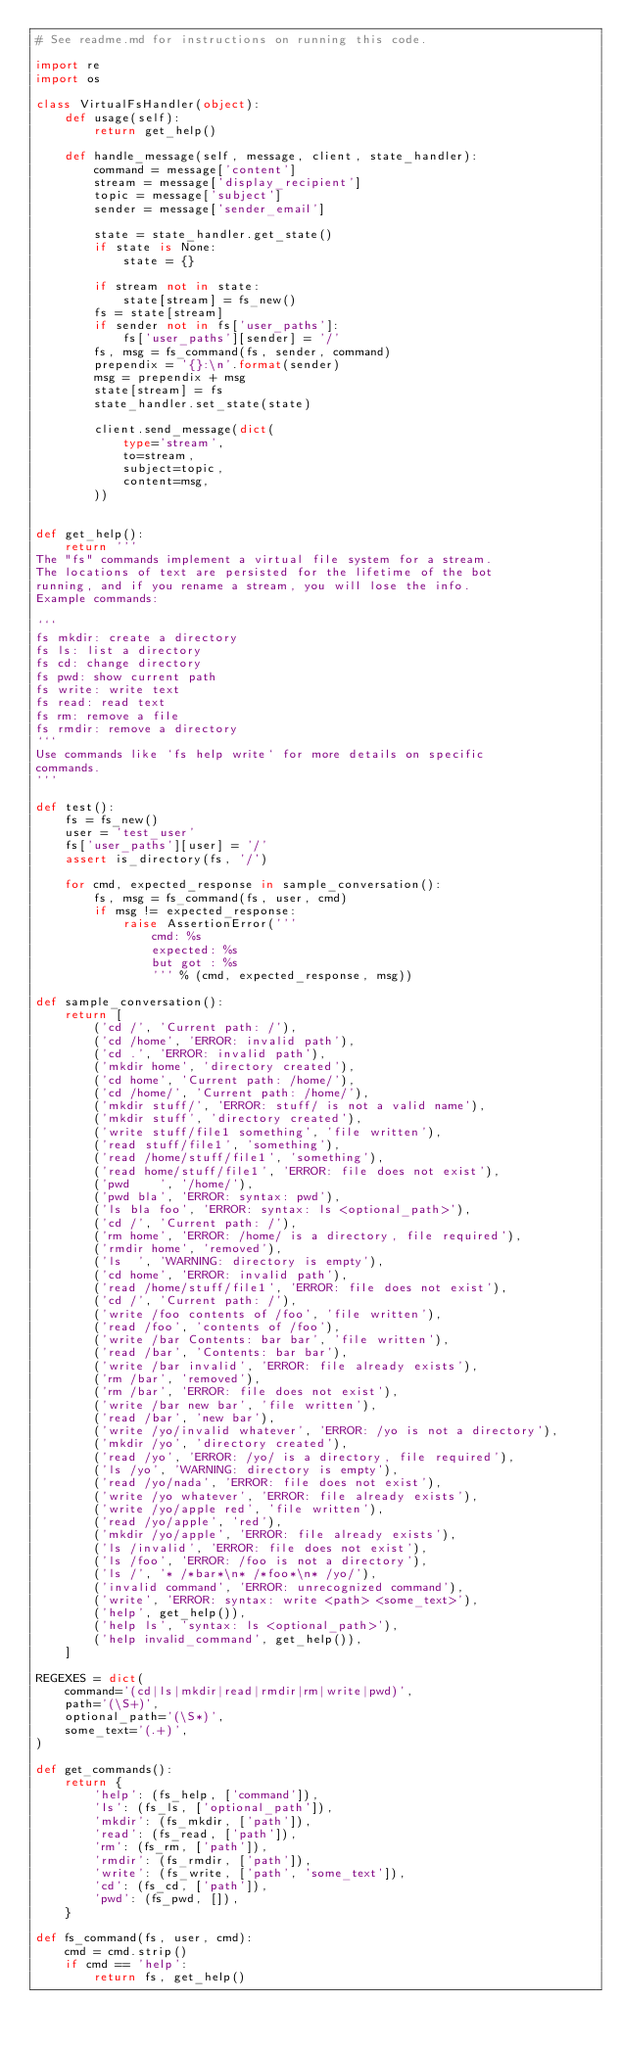<code> <loc_0><loc_0><loc_500><loc_500><_Python_># See readme.md for instructions on running this code.

import re
import os

class VirtualFsHandler(object):
    def usage(self):
        return get_help()

    def handle_message(self, message, client, state_handler):
        command = message['content']
        stream = message['display_recipient']
        topic = message['subject']
        sender = message['sender_email']

        state = state_handler.get_state()
        if state is None:
            state = {}

        if stream not in state:
            state[stream] = fs_new()
        fs = state[stream]
        if sender not in fs['user_paths']:
            fs['user_paths'][sender] = '/'
        fs, msg = fs_command(fs, sender, command)
        prependix = '{}:\n'.format(sender)
        msg = prependix + msg
        state[stream] = fs
        state_handler.set_state(state)

        client.send_message(dict(
            type='stream',
            to=stream,
            subject=topic,
            content=msg,
        ))


def get_help():
    return '''
The "fs" commands implement a virtual file system for a stream.
The locations of text are persisted for the lifetime of the bot
running, and if you rename a stream, you will lose the info.
Example commands:

```
fs mkdir: create a directory
fs ls: list a directory
fs cd: change directory
fs pwd: show current path
fs write: write text
fs read: read text
fs rm: remove a file
fs rmdir: remove a directory
```
Use commands like `fs help write` for more details on specific
commands.
'''

def test():
    fs = fs_new()
    user = 'test_user'
    fs['user_paths'][user] = '/'
    assert is_directory(fs, '/')

    for cmd, expected_response in sample_conversation():
        fs, msg = fs_command(fs, user, cmd)
        if msg != expected_response:
            raise AssertionError('''
                cmd: %s
                expected: %s
                but got : %s
                ''' % (cmd, expected_response, msg))

def sample_conversation():
    return [
        ('cd /', 'Current path: /'),
        ('cd /home', 'ERROR: invalid path'),
        ('cd .', 'ERROR: invalid path'),
        ('mkdir home', 'directory created'),
        ('cd home', 'Current path: /home/'),
        ('cd /home/', 'Current path: /home/'),
        ('mkdir stuff/', 'ERROR: stuff/ is not a valid name'),
        ('mkdir stuff', 'directory created'),
        ('write stuff/file1 something', 'file written'),
        ('read stuff/file1', 'something'),
        ('read /home/stuff/file1', 'something'),
        ('read home/stuff/file1', 'ERROR: file does not exist'),
        ('pwd    ', '/home/'),
        ('pwd bla', 'ERROR: syntax: pwd'),
        ('ls bla foo', 'ERROR: syntax: ls <optional_path>'),
        ('cd /', 'Current path: /'),
        ('rm home', 'ERROR: /home/ is a directory, file required'),
        ('rmdir home', 'removed'),
        ('ls  ', 'WARNING: directory is empty'),
        ('cd home', 'ERROR: invalid path'),
        ('read /home/stuff/file1', 'ERROR: file does not exist'),
        ('cd /', 'Current path: /'),
        ('write /foo contents of /foo', 'file written'),
        ('read /foo', 'contents of /foo'),
        ('write /bar Contents: bar bar', 'file written'),
        ('read /bar', 'Contents: bar bar'),
        ('write /bar invalid', 'ERROR: file already exists'),
        ('rm /bar', 'removed'),
        ('rm /bar', 'ERROR: file does not exist'),
        ('write /bar new bar', 'file written'),
        ('read /bar', 'new bar'),
        ('write /yo/invalid whatever', 'ERROR: /yo is not a directory'),
        ('mkdir /yo', 'directory created'),
        ('read /yo', 'ERROR: /yo/ is a directory, file required'),
        ('ls /yo', 'WARNING: directory is empty'),
        ('read /yo/nada', 'ERROR: file does not exist'),
        ('write /yo whatever', 'ERROR: file already exists'),
        ('write /yo/apple red', 'file written'),
        ('read /yo/apple', 'red'),
        ('mkdir /yo/apple', 'ERROR: file already exists'),
        ('ls /invalid', 'ERROR: file does not exist'),
        ('ls /foo', 'ERROR: /foo is not a directory'),
        ('ls /', '* /*bar*\n* /*foo*\n* /yo/'),
        ('invalid command', 'ERROR: unrecognized command'),
        ('write', 'ERROR: syntax: write <path> <some_text>'),
        ('help', get_help()),
        ('help ls', 'syntax: ls <optional_path>'),
        ('help invalid_command', get_help()),
    ]

REGEXES = dict(
    command='(cd|ls|mkdir|read|rmdir|rm|write|pwd)',
    path='(\S+)',
    optional_path='(\S*)',
    some_text='(.+)',
)

def get_commands():
    return {
        'help': (fs_help, ['command']),
        'ls': (fs_ls, ['optional_path']),
        'mkdir': (fs_mkdir, ['path']),
        'read': (fs_read, ['path']),
        'rm': (fs_rm, ['path']),
        'rmdir': (fs_rmdir, ['path']),
        'write': (fs_write, ['path', 'some_text']),
        'cd': (fs_cd, ['path']),
        'pwd': (fs_pwd, []),
    }

def fs_command(fs, user, cmd):
    cmd = cmd.strip()
    if cmd == 'help':
        return fs, get_help()</code> 